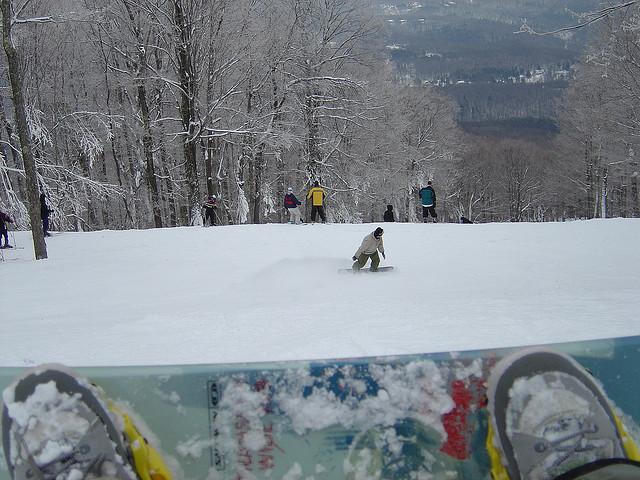Is the snowboarder on a lift?
Answer briefly. No. Can this activity be done in the summertime?
Concise answer only. No. What time of the year is it?
Give a very brief answer. Winter. What are the people doing?
Be succinct. Snowboarding. 